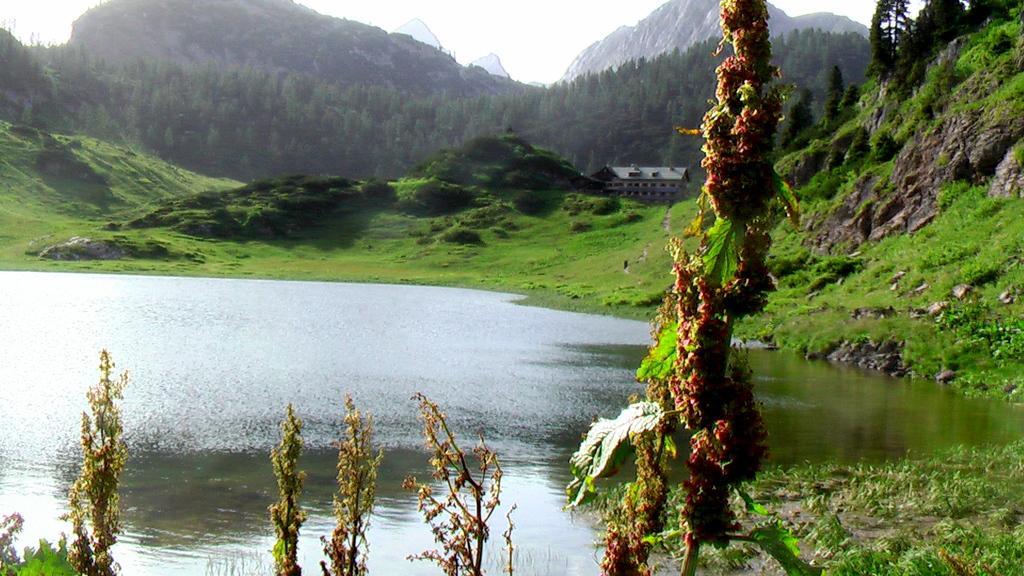Please provide a concise description of this image. In this picture we can see mountains, trees and building. On bottom we can see water and grass. On the top there is a sky. 